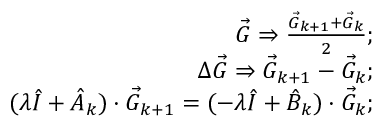<formula> <loc_0><loc_0><loc_500><loc_500>\begin{array} { r l r } & { \vec { G } \Rightarrow \frac { \vec { G } _ { k + 1 } + \vec { G } _ { k } } { 2 } ; } \\ & { \Delta \vec { G } \Rightarrow \vec { G } _ { k + 1 } - \vec { G } _ { k } ; } \\ & { ( \lambda \hat { I } + \hat { A } _ { k } ) \cdot \vec { G } _ { k + 1 } = ( - \lambda \hat { I } + \hat { B } _ { k } ) \cdot \vec { G } _ { k } ; } \end{array}</formula> 